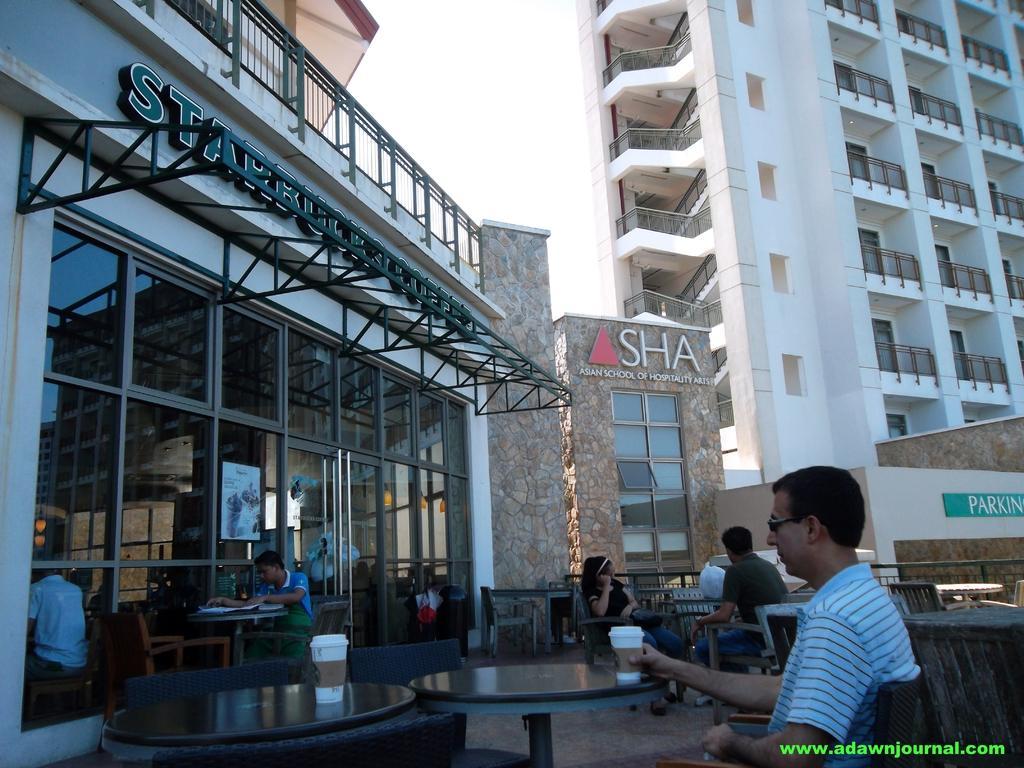Describe this image in one or two sentences. In this picture I can see there are few people sitting and drinking coffee, there is a coffee shop and in the backdrop there are buildings and the sky is clear. 